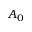Convert formula to latex. <formula><loc_0><loc_0><loc_500><loc_500>A _ { 0 }</formula> 